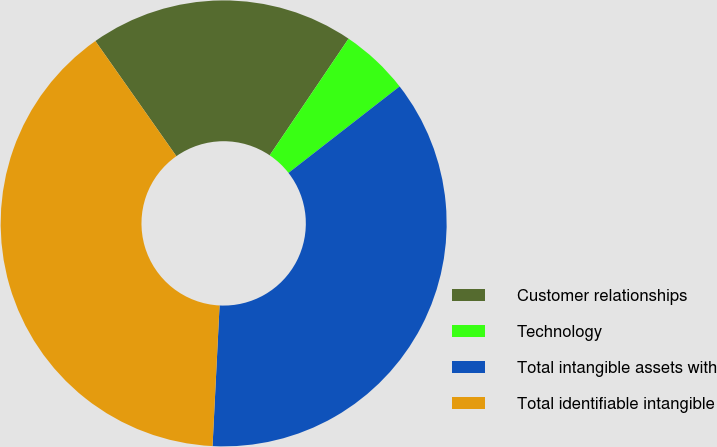Convert chart. <chart><loc_0><loc_0><loc_500><loc_500><pie_chart><fcel>Customer relationships<fcel>Technology<fcel>Total intangible assets with<fcel>Total identifiable intangible<nl><fcel>19.22%<fcel>5.01%<fcel>36.32%<fcel>39.45%<nl></chart> 